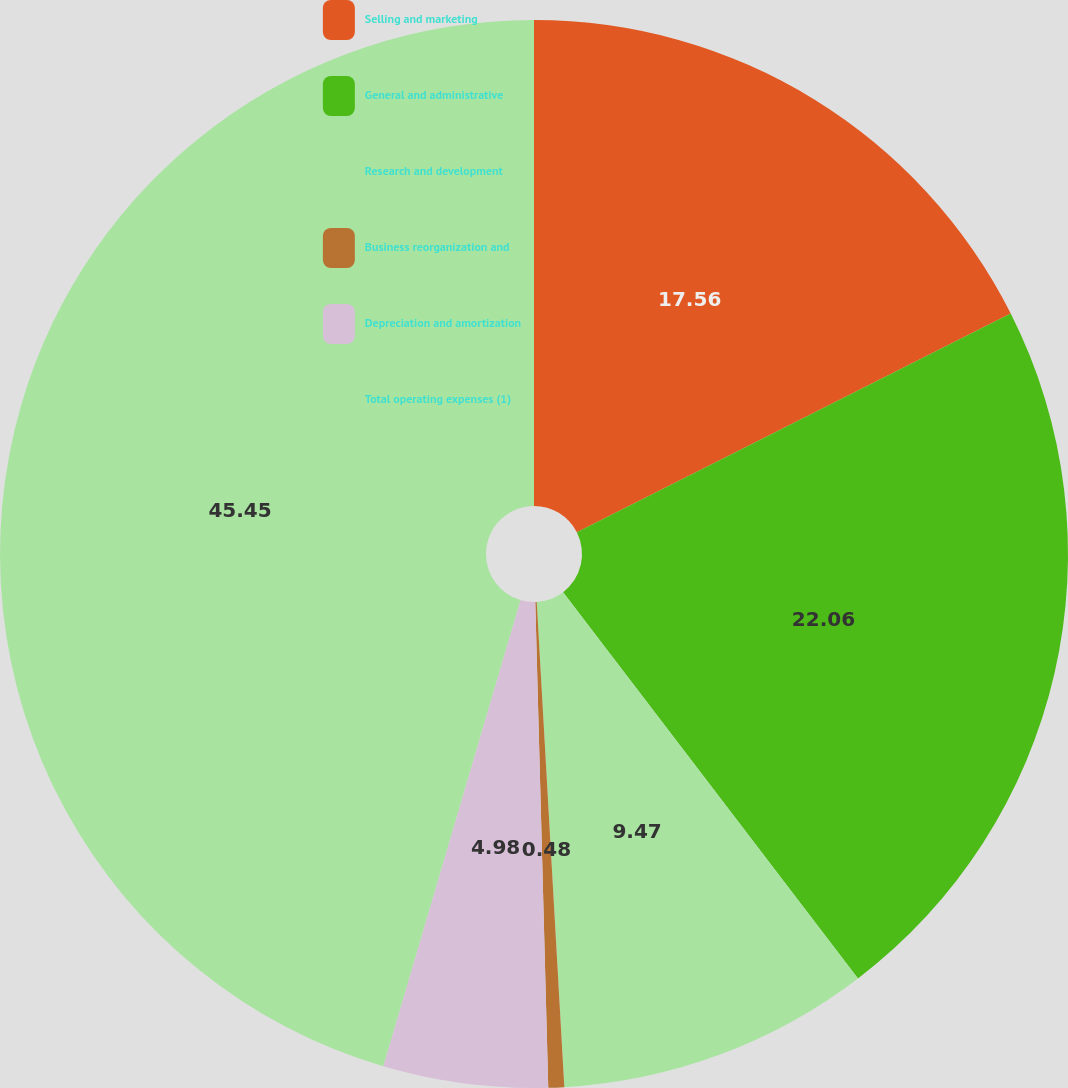<chart> <loc_0><loc_0><loc_500><loc_500><pie_chart><fcel>Selling and marketing<fcel>General and administrative<fcel>Research and development<fcel>Business reorganization and<fcel>Depreciation and amortization<fcel>Total operating expenses (1)<nl><fcel>17.56%<fcel>22.06%<fcel>9.47%<fcel>0.48%<fcel>4.98%<fcel>45.44%<nl></chart> 